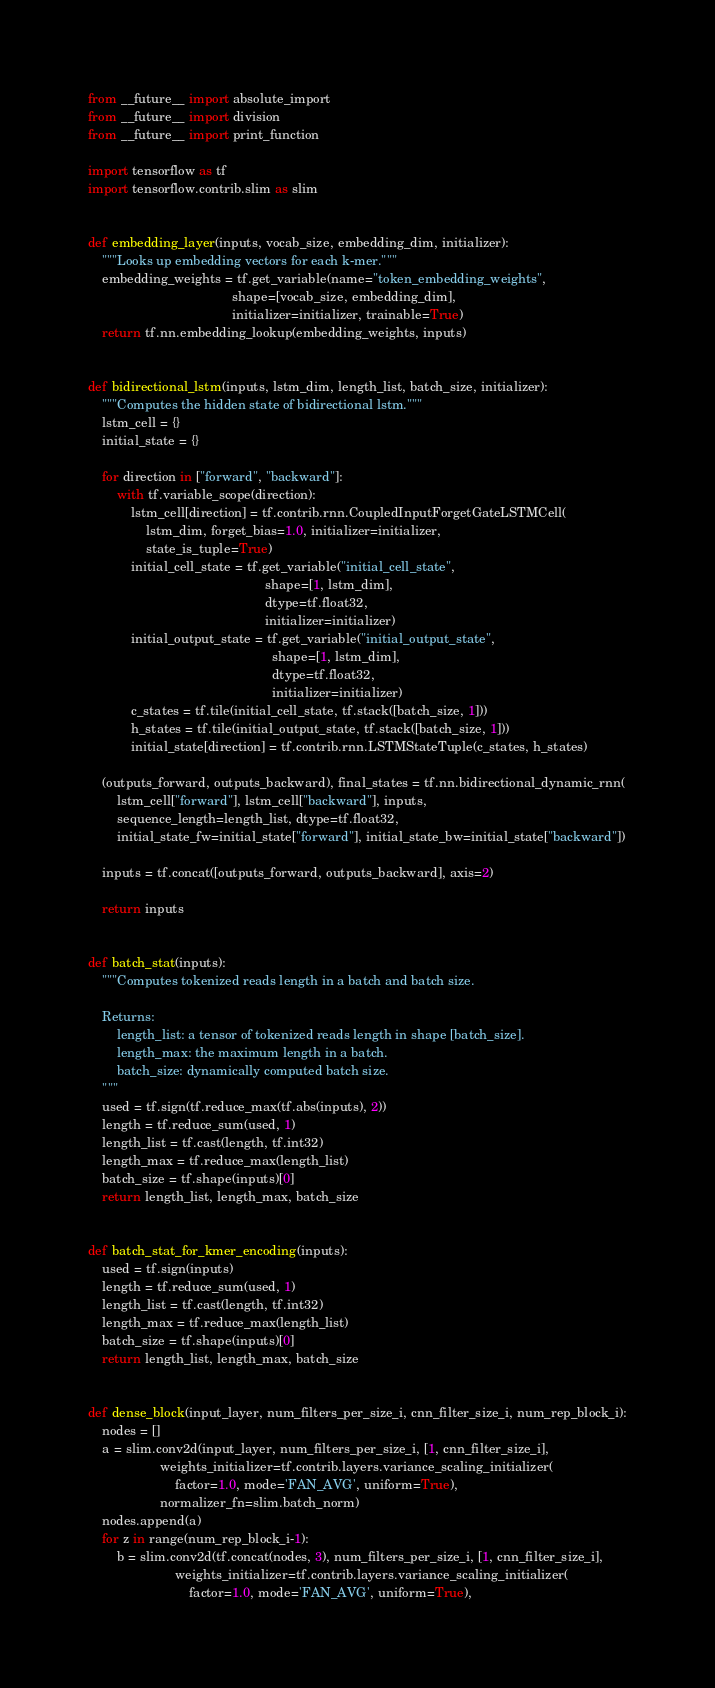<code> <loc_0><loc_0><loc_500><loc_500><_Python_>from __future__ import absolute_import
from __future__ import division
from __future__ import print_function

import tensorflow as tf
import tensorflow.contrib.slim as slim


def embedding_layer(inputs, vocab_size, embedding_dim, initializer):
    """Looks up embedding vectors for each k-mer."""
    embedding_weights = tf.get_variable(name="token_embedding_weights",
                                        shape=[vocab_size, embedding_dim],
                                        initializer=initializer, trainable=True)
    return tf.nn.embedding_lookup(embedding_weights, inputs)


def bidirectional_lstm(inputs, lstm_dim, length_list, batch_size, initializer):
    """Computes the hidden state of bidirectional lstm."""
    lstm_cell = {}
    initial_state = {}

    for direction in ["forward", "backward"]:
        with tf.variable_scope(direction):
            lstm_cell[direction] = tf.contrib.rnn.CoupledInputForgetGateLSTMCell(
                lstm_dim, forget_bias=1.0, initializer=initializer,
                state_is_tuple=True)
            initial_cell_state = tf.get_variable("initial_cell_state",
                                                 shape=[1, lstm_dim],
                                                 dtype=tf.float32,
                                                 initializer=initializer)
            initial_output_state = tf.get_variable("initial_output_state",
                                                   shape=[1, lstm_dim],
                                                   dtype=tf.float32,
                                                   initializer=initializer)
            c_states = tf.tile(initial_cell_state, tf.stack([batch_size, 1]))
            h_states = tf.tile(initial_output_state, tf.stack([batch_size, 1]))
            initial_state[direction] = tf.contrib.rnn.LSTMStateTuple(c_states, h_states)

    (outputs_forward, outputs_backward), final_states = tf.nn.bidirectional_dynamic_rnn(
        lstm_cell["forward"], lstm_cell["backward"], inputs,
        sequence_length=length_list, dtype=tf.float32,
        initial_state_fw=initial_state["forward"], initial_state_bw=initial_state["backward"])

    inputs = tf.concat([outputs_forward, outputs_backward], axis=2)

    return inputs


def batch_stat(inputs):
    """Computes tokenized reads length in a batch and batch size.

    Returns:
        length_list: a tensor of tokenized reads length in shape [batch_size].
        length_max: the maximum length in a batch.
        batch_size: dynamically computed batch size.
    """
    used = tf.sign(tf.reduce_max(tf.abs(inputs), 2))
    length = tf.reduce_sum(used, 1)
    length_list = tf.cast(length, tf.int32)
    length_max = tf.reduce_max(length_list)
    batch_size = tf.shape(inputs)[0]
    return length_list, length_max, batch_size


def batch_stat_for_kmer_encoding(inputs):
    used = tf.sign(inputs)
    length = tf.reduce_sum(used, 1)
    length_list = tf.cast(length, tf.int32)
    length_max = tf.reduce_max(length_list)
    batch_size = tf.shape(inputs)[0]
    return length_list, length_max, batch_size


def dense_block(input_layer, num_filters_per_size_i, cnn_filter_size_i, num_rep_block_i):
    nodes = []
    a = slim.conv2d(input_layer, num_filters_per_size_i, [1, cnn_filter_size_i],
                    weights_initializer=tf.contrib.layers.variance_scaling_initializer(
                        factor=1.0, mode='FAN_AVG', uniform=True),
                    normalizer_fn=slim.batch_norm)
    nodes.append(a)
    for z in range(num_rep_block_i-1):
        b = slim.conv2d(tf.concat(nodes, 3), num_filters_per_size_i, [1, cnn_filter_size_i],
                        weights_initializer=tf.contrib.layers.variance_scaling_initializer(
                            factor=1.0, mode='FAN_AVG', uniform=True),</code> 